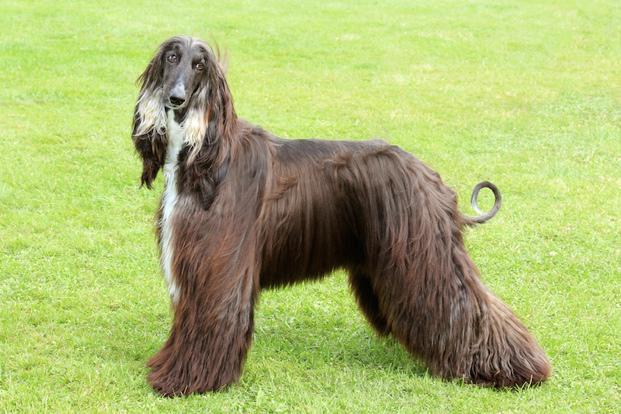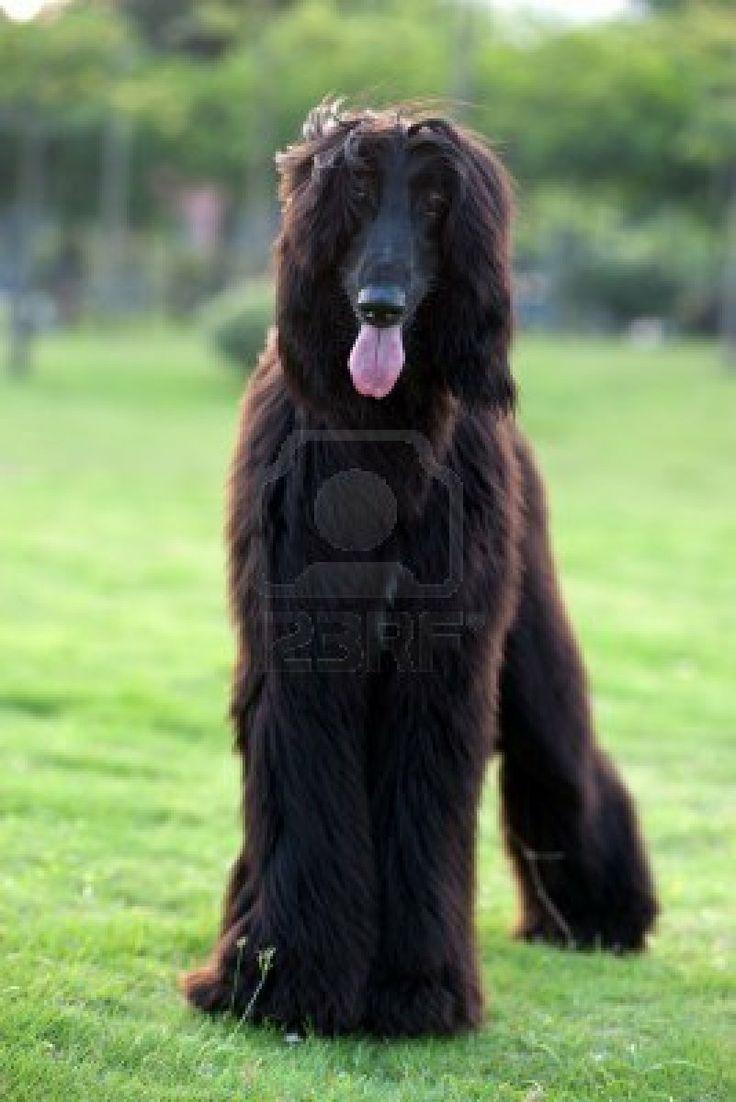The first image is the image on the left, the second image is the image on the right. Considering the images on both sides, is "The left and right image contains the same number of dogs facing opposite directions." valid? Answer yes or no. No. The first image is the image on the left, the second image is the image on the right. Assess this claim about the two images: "The dogs are oriented in opposite directions.". Correct or not? Answer yes or no. No. 